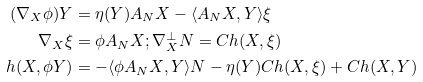<formula> <loc_0><loc_0><loc_500><loc_500>( \nabla _ { X } \phi ) Y & = \eta ( Y ) A _ { N } X - \langle A _ { N } X , Y \rangle \xi \\ \nabla _ { X } \xi & = \phi A _ { N } X ; \nabla ^ { \perp } _ { X } N = C h ( X , \xi ) \\ h ( X , \phi Y ) & = - \langle \phi A _ { N } X , Y \rangle N - \eta ( Y ) C h ( X , \xi ) + C h ( X , Y )</formula> 